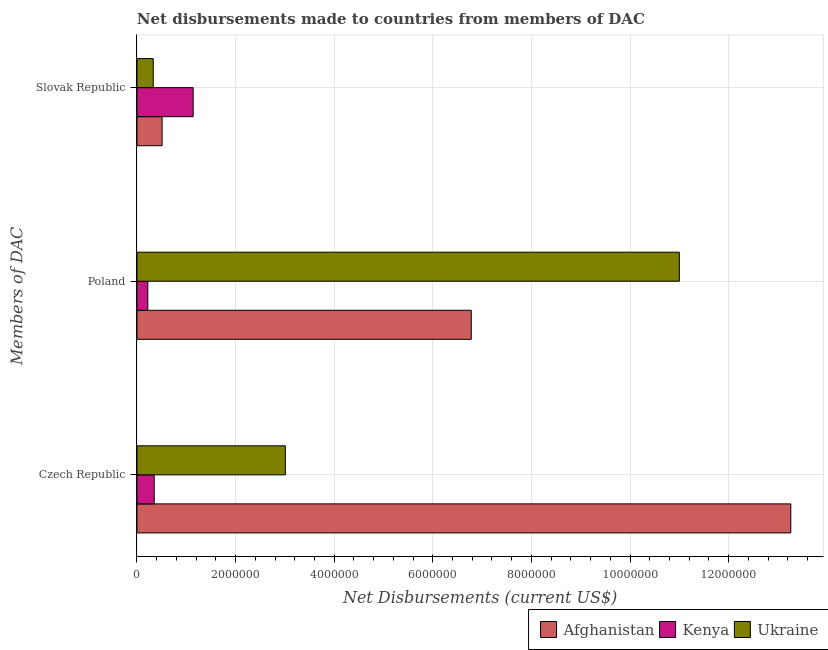Are the number of bars on each tick of the Y-axis equal?
Ensure brevity in your answer.  Yes. What is the label of the 1st group of bars from the top?
Your answer should be compact. Slovak Republic. What is the net disbursements made by poland in Ukraine?
Make the answer very short. 1.10e+07. Across all countries, what is the maximum net disbursements made by slovak republic?
Provide a succinct answer. 1.14e+06. Across all countries, what is the minimum net disbursements made by czech republic?
Provide a succinct answer. 3.50e+05. In which country was the net disbursements made by czech republic maximum?
Give a very brief answer. Afghanistan. In which country was the net disbursements made by poland minimum?
Keep it short and to the point. Kenya. What is the total net disbursements made by czech republic in the graph?
Offer a terse response. 1.66e+07. What is the difference between the net disbursements made by poland in Kenya and that in Ukraine?
Make the answer very short. -1.08e+07. What is the difference between the net disbursements made by poland in Afghanistan and the net disbursements made by slovak republic in Ukraine?
Make the answer very short. 6.45e+06. What is the average net disbursements made by czech republic per country?
Offer a terse response. 5.54e+06. What is the difference between the net disbursements made by czech republic and net disbursements made by poland in Kenya?
Make the answer very short. 1.30e+05. What is the ratio of the net disbursements made by poland in Kenya to that in Afghanistan?
Give a very brief answer. 0.03. What is the difference between the highest and the second highest net disbursements made by czech republic?
Your answer should be very brief. 1.02e+07. What is the difference between the highest and the lowest net disbursements made by poland?
Offer a terse response. 1.08e+07. What does the 3rd bar from the top in Slovak Republic represents?
Your answer should be compact. Afghanistan. What does the 2nd bar from the bottom in Czech Republic represents?
Your answer should be very brief. Kenya. How many bars are there?
Offer a terse response. 9. Are all the bars in the graph horizontal?
Make the answer very short. Yes. What is the difference between two consecutive major ticks on the X-axis?
Keep it short and to the point. 2.00e+06. Where does the legend appear in the graph?
Keep it short and to the point. Bottom right. How many legend labels are there?
Your response must be concise. 3. What is the title of the graph?
Your response must be concise. Net disbursements made to countries from members of DAC. Does "Saudi Arabia" appear as one of the legend labels in the graph?
Provide a succinct answer. No. What is the label or title of the X-axis?
Your response must be concise. Net Disbursements (current US$). What is the label or title of the Y-axis?
Keep it short and to the point. Members of DAC. What is the Net Disbursements (current US$) in Afghanistan in Czech Republic?
Ensure brevity in your answer.  1.33e+07. What is the Net Disbursements (current US$) of Ukraine in Czech Republic?
Keep it short and to the point. 3.01e+06. What is the Net Disbursements (current US$) of Afghanistan in Poland?
Provide a succinct answer. 6.78e+06. What is the Net Disbursements (current US$) in Ukraine in Poland?
Give a very brief answer. 1.10e+07. What is the Net Disbursements (current US$) of Afghanistan in Slovak Republic?
Ensure brevity in your answer.  5.10e+05. What is the Net Disbursements (current US$) of Kenya in Slovak Republic?
Make the answer very short. 1.14e+06. What is the Net Disbursements (current US$) of Ukraine in Slovak Republic?
Your response must be concise. 3.30e+05. Across all Members of DAC, what is the maximum Net Disbursements (current US$) of Afghanistan?
Provide a succinct answer. 1.33e+07. Across all Members of DAC, what is the maximum Net Disbursements (current US$) in Kenya?
Ensure brevity in your answer.  1.14e+06. Across all Members of DAC, what is the maximum Net Disbursements (current US$) in Ukraine?
Provide a short and direct response. 1.10e+07. Across all Members of DAC, what is the minimum Net Disbursements (current US$) in Afghanistan?
Ensure brevity in your answer.  5.10e+05. Across all Members of DAC, what is the minimum Net Disbursements (current US$) of Kenya?
Keep it short and to the point. 2.20e+05. Across all Members of DAC, what is the minimum Net Disbursements (current US$) of Ukraine?
Provide a short and direct response. 3.30e+05. What is the total Net Disbursements (current US$) in Afghanistan in the graph?
Your response must be concise. 2.06e+07. What is the total Net Disbursements (current US$) in Kenya in the graph?
Your answer should be compact. 1.71e+06. What is the total Net Disbursements (current US$) in Ukraine in the graph?
Make the answer very short. 1.43e+07. What is the difference between the Net Disbursements (current US$) in Afghanistan in Czech Republic and that in Poland?
Make the answer very short. 6.48e+06. What is the difference between the Net Disbursements (current US$) of Kenya in Czech Republic and that in Poland?
Provide a succinct answer. 1.30e+05. What is the difference between the Net Disbursements (current US$) of Ukraine in Czech Republic and that in Poland?
Ensure brevity in your answer.  -7.99e+06. What is the difference between the Net Disbursements (current US$) of Afghanistan in Czech Republic and that in Slovak Republic?
Make the answer very short. 1.28e+07. What is the difference between the Net Disbursements (current US$) in Kenya in Czech Republic and that in Slovak Republic?
Give a very brief answer. -7.90e+05. What is the difference between the Net Disbursements (current US$) of Ukraine in Czech Republic and that in Slovak Republic?
Ensure brevity in your answer.  2.68e+06. What is the difference between the Net Disbursements (current US$) of Afghanistan in Poland and that in Slovak Republic?
Give a very brief answer. 6.27e+06. What is the difference between the Net Disbursements (current US$) of Kenya in Poland and that in Slovak Republic?
Your answer should be very brief. -9.20e+05. What is the difference between the Net Disbursements (current US$) of Ukraine in Poland and that in Slovak Republic?
Provide a short and direct response. 1.07e+07. What is the difference between the Net Disbursements (current US$) in Afghanistan in Czech Republic and the Net Disbursements (current US$) in Kenya in Poland?
Offer a very short reply. 1.30e+07. What is the difference between the Net Disbursements (current US$) of Afghanistan in Czech Republic and the Net Disbursements (current US$) of Ukraine in Poland?
Your response must be concise. 2.26e+06. What is the difference between the Net Disbursements (current US$) of Kenya in Czech Republic and the Net Disbursements (current US$) of Ukraine in Poland?
Ensure brevity in your answer.  -1.06e+07. What is the difference between the Net Disbursements (current US$) in Afghanistan in Czech Republic and the Net Disbursements (current US$) in Kenya in Slovak Republic?
Keep it short and to the point. 1.21e+07. What is the difference between the Net Disbursements (current US$) in Afghanistan in Czech Republic and the Net Disbursements (current US$) in Ukraine in Slovak Republic?
Keep it short and to the point. 1.29e+07. What is the difference between the Net Disbursements (current US$) in Afghanistan in Poland and the Net Disbursements (current US$) in Kenya in Slovak Republic?
Your response must be concise. 5.64e+06. What is the difference between the Net Disbursements (current US$) of Afghanistan in Poland and the Net Disbursements (current US$) of Ukraine in Slovak Republic?
Make the answer very short. 6.45e+06. What is the difference between the Net Disbursements (current US$) in Kenya in Poland and the Net Disbursements (current US$) in Ukraine in Slovak Republic?
Give a very brief answer. -1.10e+05. What is the average Net Disbursements (current US$) of Afghanistan per Members of DAC?
Ensure brevity in your answer.  6.85e+06. What is the average Net Disbursements (current US$) of Kenya per Members of DAC?
Ensure brevity in your answer.  5.70e+05. What is the average Net Disbursements (current US$) of Ukraine per Members of DAC?
Keep it short and to the point. 4.78e+06. What is the difference between the Net Disbursements (current US$) of Afghanistan and Net Disbursements (current US$) of Kenya in Czech Republic?
Offer a terse response. 1.29e+07. What is the difference between the Net Disbursements (current US$) of Afghanistan and Net Disbursements (current US$) of Ukraine in Czech Republic?
Provide a short and direct response. 1.02e+07. What is the difference between the Net Disbursements (current US$) in Kenya and Net Disbursements (current US$) in Ukraine in Czech Republic?
Offer a terse response. -2.66e+06. What is the difference between the Net Disbursements (current US$) of Afghanistan and Net Disbursements (current US$) of Kenya in Poland?
Offer a very short reply. 6.56e+06. What is the difference between the Net Disbursements (current US$) in Afghanistan and Net Disbursements (current US$) in Ukraine in Poland?
Keep it short and to the point. -4.22e+06. What is the difference between the Net Disbursements (current US$) in Kenya and Net Disbursements (current US$) in Ukraine in Poland?
Your response must be concise. -1.08e+07. What is the difference between the Net Disbursements (current US$) of Afghanistan and Net Disbursements (current US$) of Kenya in Slovak Republic?
Make the answer very short. -6.30e+05. What is the difference between the Net Disbursements (current US$) in Kenya and Net Disbursements (current US$) in Ukraine in Slovak Republic?
Offer a very short reply. 8.10e+05. What is the ratio of the Net Disbursements (current US$) in Afghanistan in Czech Republic to that in Poland?
Keep it short and to the point. 1.96. What is the ratio of the Net Disbursements (current US$) in Kenya in Czech Republic to that in Poland?
Your answer should be compact. 1.59. What is the ratio of the Net Disbursements (current US$) of Ukraine in Czech Republic to that in Poland?
Your answer should be compact. 0.27. What is the ratio of the Net Disbursements (current US$) of Afghanistan in Czech Republic to that in Slovak Republic?
Offer a terse response. 26. What is the ratio of the Net Disbursements (current US$) in Kenya in Czech Republic to that in Slovak Republic?
Keep it short and to the point. 0.31. What is the ratio of the Net Disbursements (current US$) in Ukraine in Czech Republic to that in Slovak Republic?
Keep it short and to the point. 9.12. What is the ratio of the Net Disbursements (current US$) of Afghanistan in Poland to that in Slovak Republic?
Your answer should be very brief. 13.29. What is the ratio of the Net Disbursements (current US$) of Kenya in Poland to that in Slovak Republic?
Ensure brevity in your answer.  0.19. What is the ratio of the Net Disbursements (current US$) of Ukraine in Poland to that in Slovak Republic?
Your answer should be very brief. 33.33. What is the difference between the highest and the second highest Net Disbursements (current US$) in Afghanistan?
Your response must be concise. 6.48e+06. What is the difference between the highest and the second highest Net Disbursements (current US$) of Kenya?
Keep it short and to the point. 7.90e+05. What is the difference between the highest and the second highest Net Disbursements (current US$) in Ukraine?
Offer a very short reply. 7.99e+06. What is the difference between the highest and the lowest Net Disbursements (current US$) of Afghanistan?
Give a very brief answer. 1.28e+07. What is the difference between the highest and the lowest Net Disbursements (current US$) in Kenya?
Provide a succinct answer. 9.20e+05. What is the difference between the highest and the lowest Net Disbursements (current US$) in Ukraine?
Make the answer very short. 1.07e+07. 